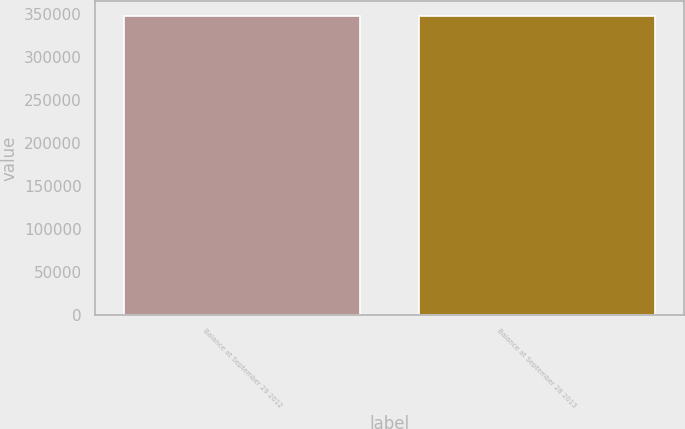<chart> <loc_0><loc_0><loc_500><loc_500><bar_chart><fcel>Balance at September 29 2012<fcel>Balance at September 28 2013<nl><fcel>348419<fcel>348419<nl></chart> 